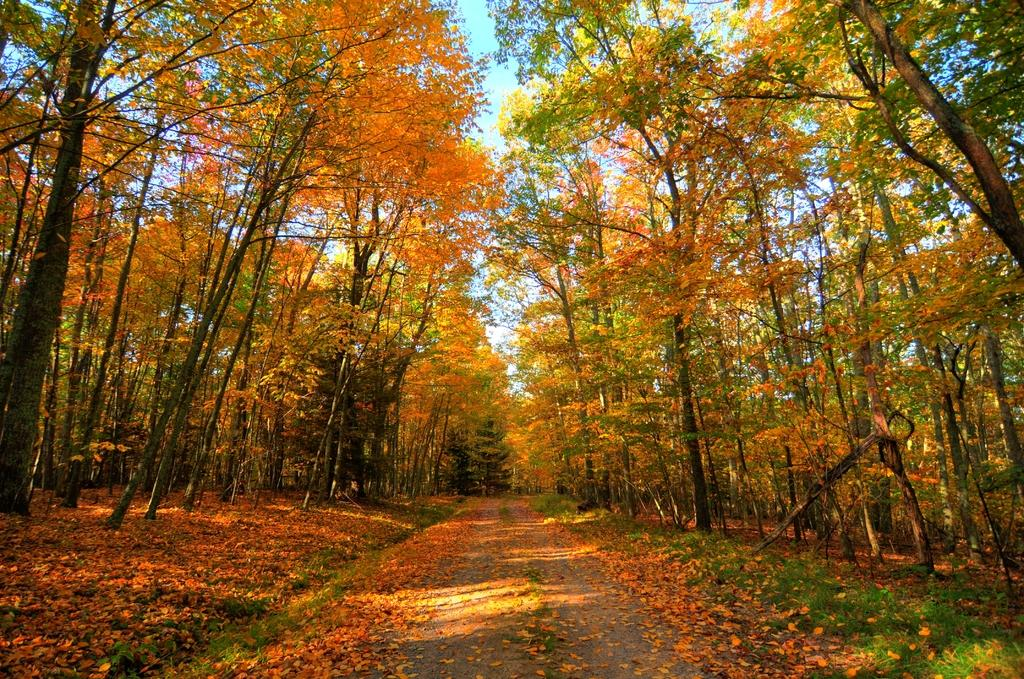What is covering the ground in the image? There are dry leaves on the ground in the image. What type of vegetation is visible in the image? There is grass in the image. What can be seen in the background of the image? There are trees in the background of the image. What type of flesh can be seen hanging from the trees in the image? There is no flesh present in the image; it features dry leaves, grass, and trees. 